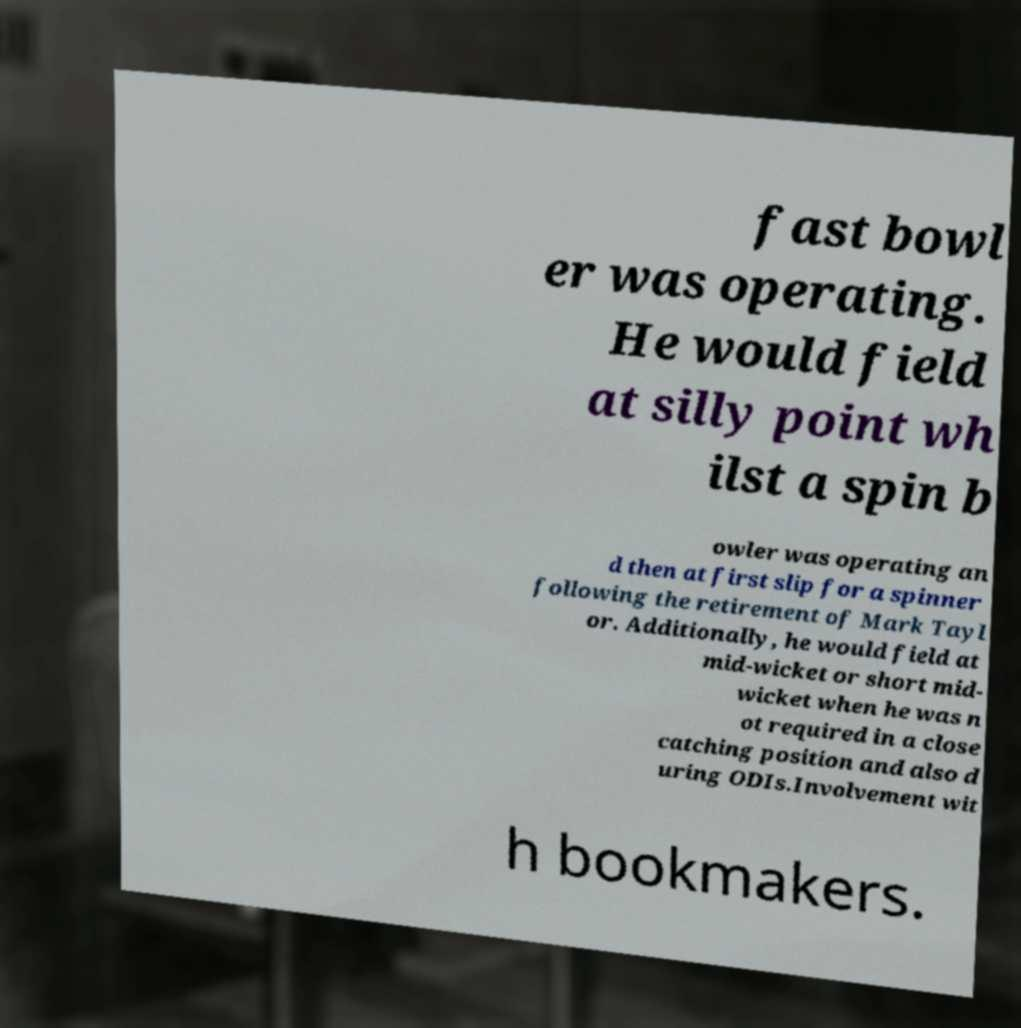I need the written content from this picture converted into text. Can you do that? fast bowl er was operating. He would field at silly point wh ilst a spin b owler was operating an d then at first slip for a spinner following the retirement of Mark Tayl or. Additionally, he would field at mid-wicket or short mid- wicket when he was n ot required in a close catching position and also d uring ODIs.Involvement wit h bookmakers. 